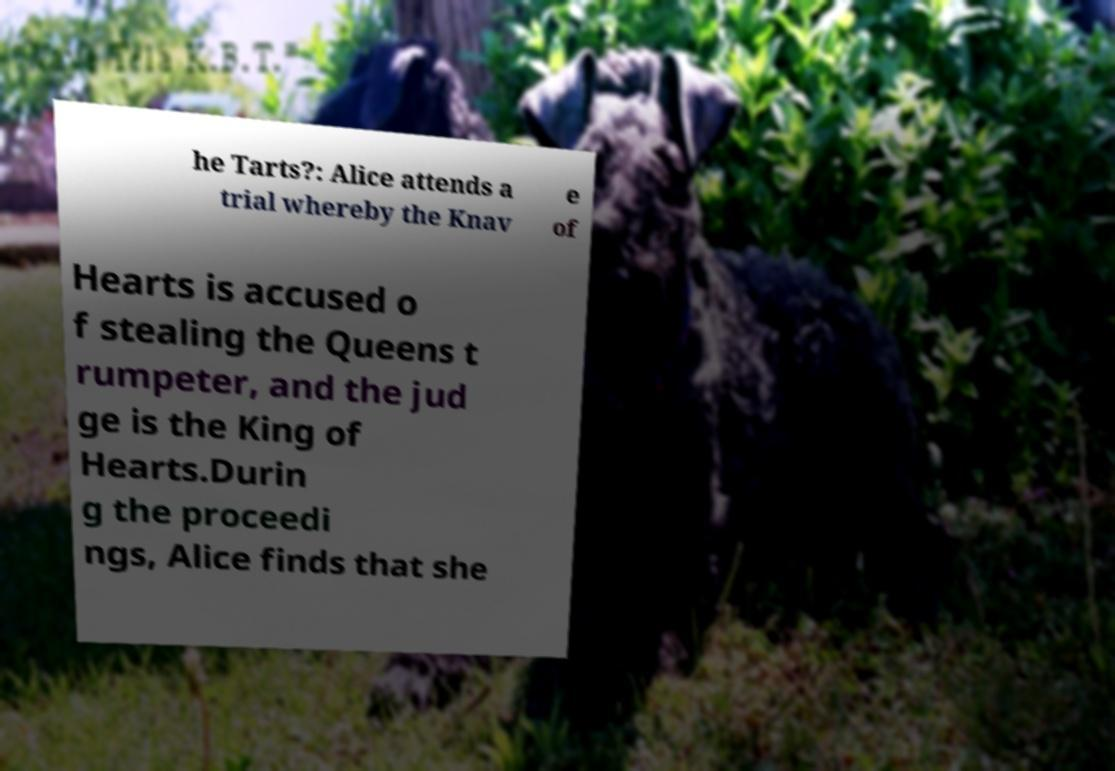Can you accurately transcribe the text from the provided image for me? he Tarts?: Alice attends a trial whereby the Knav e of Hearts is accused o f stealing the Queens t rumpeter, and the jud ge is the King of Hearts.Durin g the proceedi ngs, Alice finds that she 